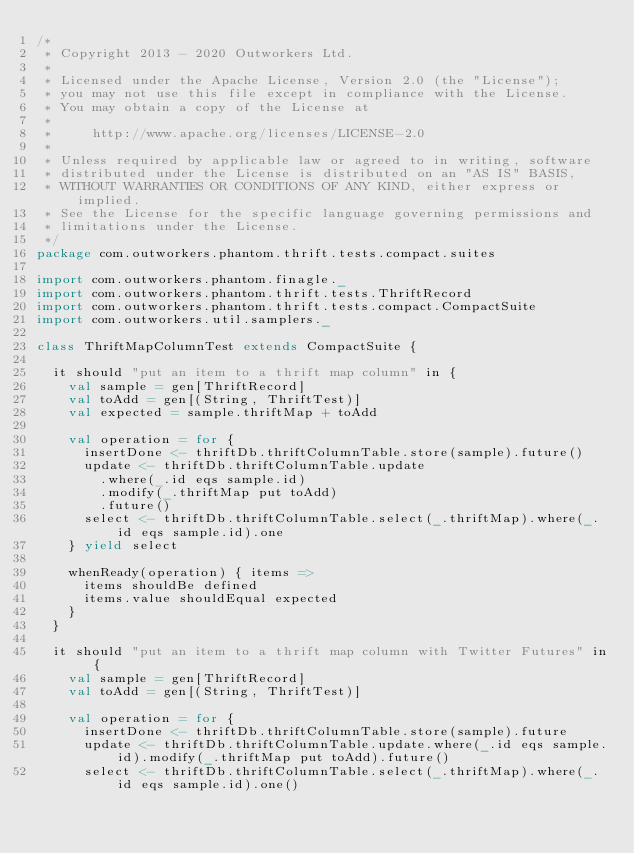Convert code to text. <code><loc_0><loc_0><loc_500><loc_500><_Scala_>/*
 * Copyright 2013 - 2020 Outworkers Ltd.
 *
 * Licensed under the Apache License, Version 2.0 (the "License");
 * you may not use this file except in compliance with the License.
 * You may obtain a copy of the License at
 *
 *     http://www.apache.org/licenses/LICENSE-2.0
 *
 * Unless required by applicable law or agreed to in writing, software
 * distributed under the License is distributed on an "AS IS" BASIS,
 * WITHOUT WARRANTIES OR CONDITIONS OF ANY KIND, either express or implied.
 * See the License for the specific language governing permissions and
 * limitations under the License.
 */
package com.outworkers.phantom.thrift.tests.compact.suites

import com.outworkers.phantom.finagle._
import com.outworkers.phantom.thrift.tests.ThriftRecord
import com.outworkers.phantom.thrift.tests.compact.CompactSuite
import com.outworkers.util.samplers._

class ThriftMapColumnTest extends CompactSuite {

  it should "put an item to a thrift map column" in {
    val sample = gen[ThriftRecord]
    val toAdd = gen[(String, ThriftTest)]
    val expected = sample.thriftMap + toAdd

    val operation = for {
      insertDone <- thriftDb.thriftColumnTable.store(sample).future()
      update <- thriftDb.thriftColumnTable.update
        .where(_.id eqs sample.id)
        .modify(_.thriftMap put toAdd)
        .future()
      select <- thriftDb.thriftColumnTable.select(_.thriftMap).where(_.id eqs sample.id).one
    } yield select

    whenReady(operation) { items =>
      items shouldBe defined
      items.value shouldEqual expected
    }
  }

  it should "put an item to a thrift map column with Twitter Futures" in {
    val sample = gen[ThriftRecord]
    val toAdd = gen[(String, ThriftTest)]

    val operation = for {
      insertDone <- thriftDb.thriftColumnTable.store(sample).future
      update <- thriftDb.thriftColumnTable.update.where(_.id eqs sample.id).modify(_.thriftMap put toAdd).future()
      select <- thriftDb.thriftColumnTable.select(_.thriftMap).where(_.id eqs sample.id).one()</code> 